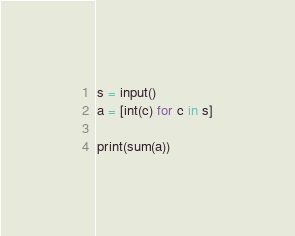<code> <loc_0><loc_0><loc_500><loc_500><_Python_>s = input()
a = [int(c) for c in s]

print(sum(a))</code> 